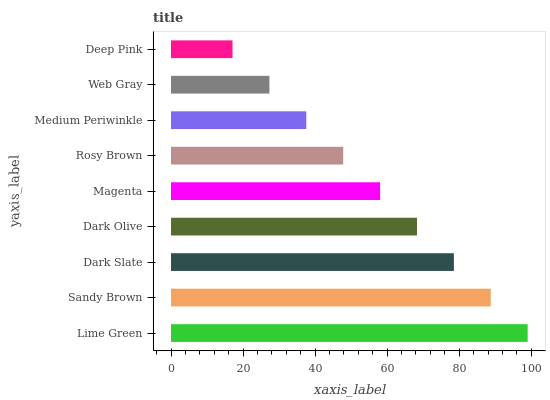Is Deep Pink the minimum?
Answer yes or no. Yes. Is Lime Green the maximum?
Answer yes or no. Yes. Is Sandy Brown the minimum?
Answer yes or no. No. Is Sandy Brown the maximum?
Answer yes or no. No. Is Lime Green greater than Sandy Brown?
Answer yes or no. Yes. Is Sandy Brown less than Lime Green?
Answer yes or no. Yes. Is Sandy Brown greater than Lime Green?
Answer yes or no. No. Is Lime Green less than Sandy Brown?
Answer yes or no. No. Is Magenta the high median?
Answer yes or no. Yes. Is Magenta the low median?
Answer yes or no. Yes. Is Deep Pink the high median?
Answer yes or no. No. Is Sandy Brown the low median?
Answer yes or no. No. 